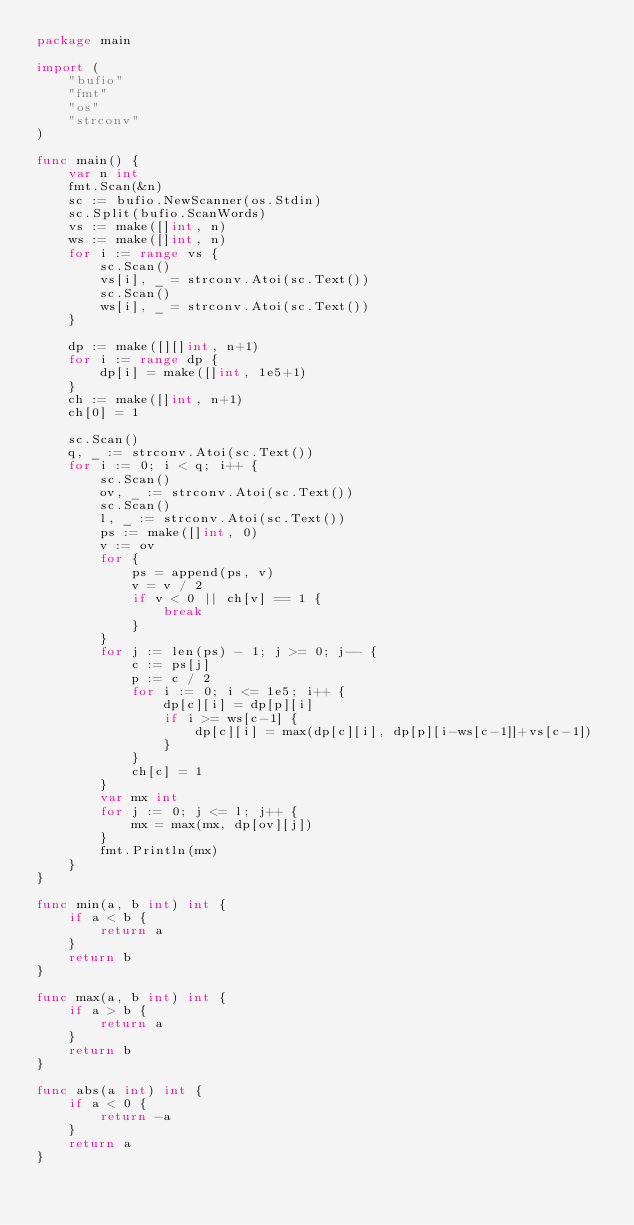Convert code to text. <code><loc_0><loc_0><loc_500><loc_500><_Go_>package main

import (
	"bufio"
	"fmt"
	"os"
	"strconv"
)

func main() {
	var n int
	fmt.Scan(&n)
	sc := bufio.NewScanner(os.Stdin)
	sc.Split(bufio.ScanWords)
	vs := make([]int, n)
	ws := make([]int, n)
	for i := range vs {
		sc.Scan()
		vs[i], _ = strconv.Atoi(sc.Text())
		sc.Scan()
		ws[i], _ = strconv.Atoi(sc.Text())
	}

	dp := make([][]int, n+1)
	for i := range dp {
		dp[i] = make([]int, 1e5+1)
	}
	ch := make([]int, n+1)
	ch[0] = 1

	sc.Scan()
	q, _ := strconv.Atoi(sc.Text())
	for i := 0; i < q; i++ {
		sc.Scan()
		ov, _ := strconv.Atoi(sc.Text())
		sc.Scan()
		l, _ := strconv.Atoi(sc.Text())
		ps := make([]int, 0)
		v := ov
		for {
			ps = append(ps, v)
			v = v / 2
			if v < 0 || ch[v] == 1 {
				break
			}
		}
		for j := len(ps) - 1; j >= 0; j-- {
			c := ps[j]
			p := c / 2
			for i := 0; i <= 1e5; i++ {
				dp[c][i] = dp[p][i]
				if i >= ws[c-1] {
					dp[c][i] = max(dp[c][i], dp[p][i-ws[c-1]]+vs[c-1])
				}
			}
			ch[c] = 1
		}
		var mx int
		for j := 0; j <= l; j++ {
			mx = max(mx, dp[ov][j])
		}
		fmt.Println(mx)
	}
}

func min(a, b int) int {
	if a < b {
		return a
	}
	return b
}

func max(a, b int) int {
	if a > b {
		return a
	}
	return b
}

func abs(a int) int {
	if a < 0 {
		return -a
	}
	return a
}
</code> 